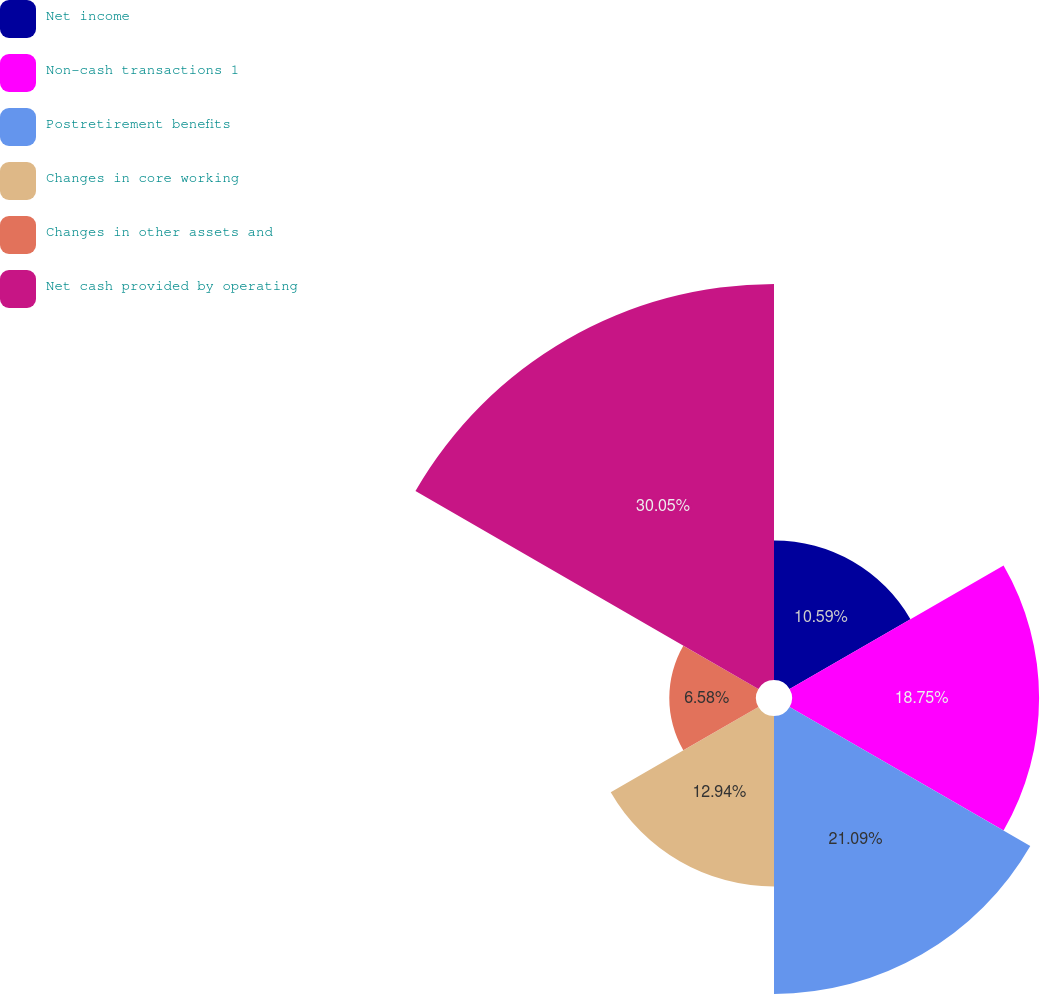Convert chart. <chart><loc_0><loc_0><loc_500><loc_500><pie_chart><fcel>Net income<fcel>Non-cash transactions 1<fcel>Postretirement benefits<fcel>Changes in core working<fcel>Changes in other assets and<fcel>Net cash provided by operating<nl><fcel>10.59%<fcel>18.75%<fcel>21.09%<fcel>12.94%<fcel>6.58%<fcel>30.05%<nl></chart> 